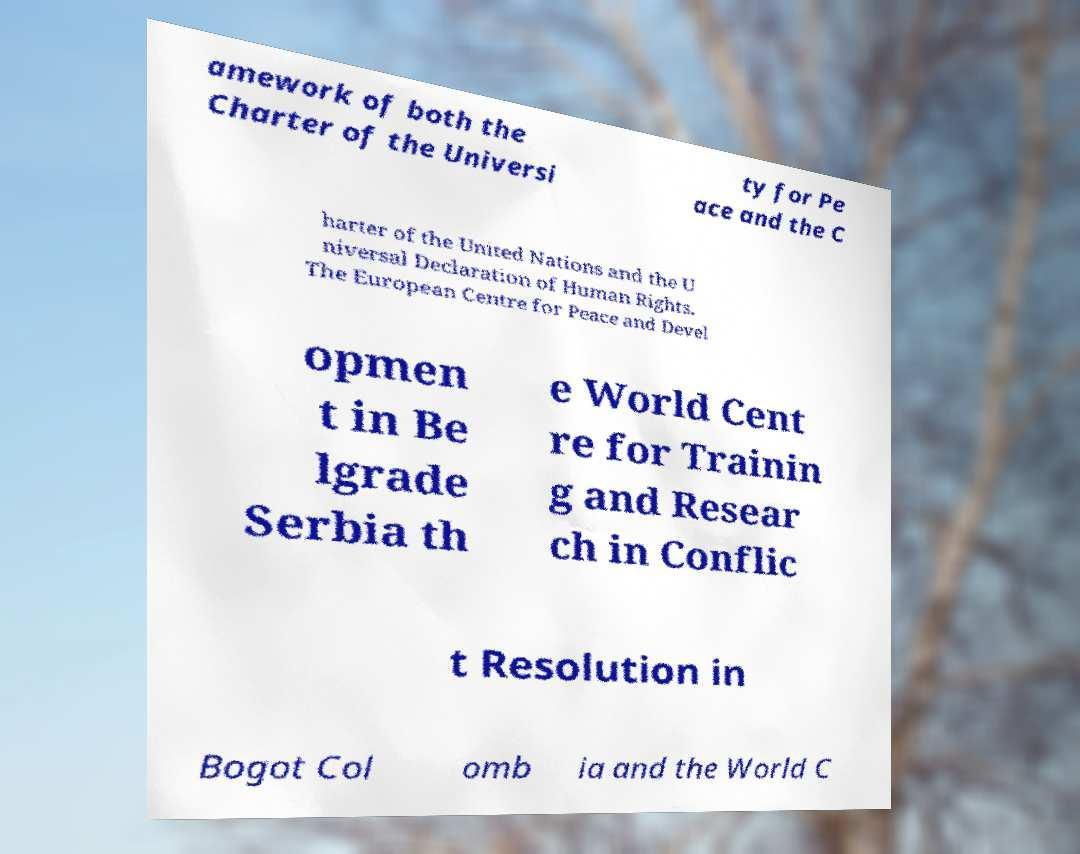Can you accurately transcribe the text from the provided image for me? amework of both the Charter of the Universi ty for Pe ace and the C harter of the United Nations and the U niversal Declaration of Human Rights. The European Centre for Peace and Devel opmen t in Be lgrade Serbia th e World Cent re for Trainin g and Resear ch in Conflic t Resolution in Bogot Col omb ia and the World C 